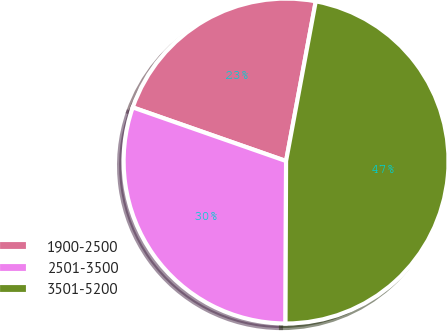Convert chart. <chart><loc_0><loc_0><loc_500><loc_500><pie_chart><fcel>1900-2500<fcel>2501-3500<fcel>3501-5200<nl><fcel>22.57%<fcel>30.3%<fcel>47.13%<nl></chart> 